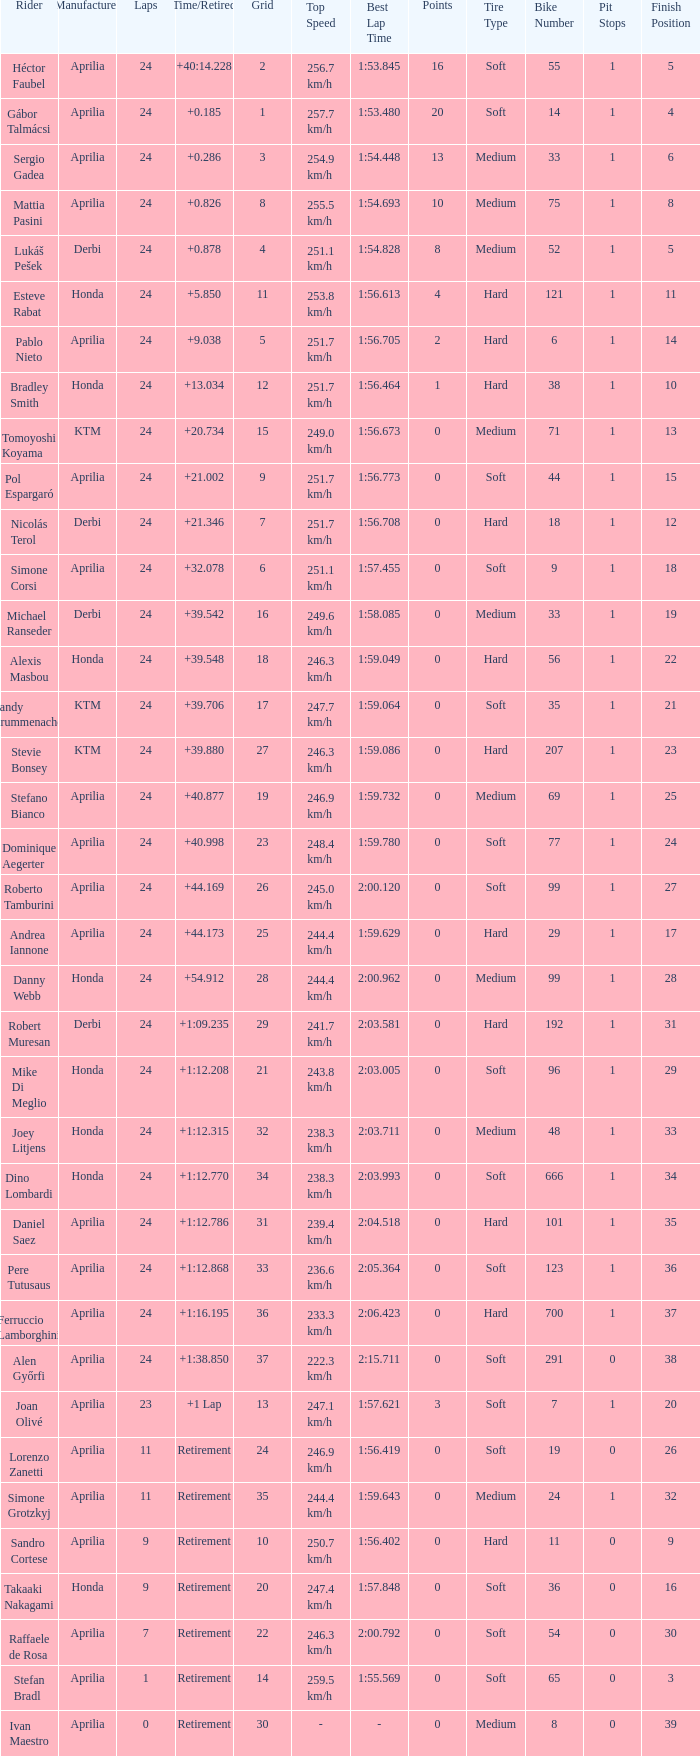What is the time with 10 grids? Retirement. 